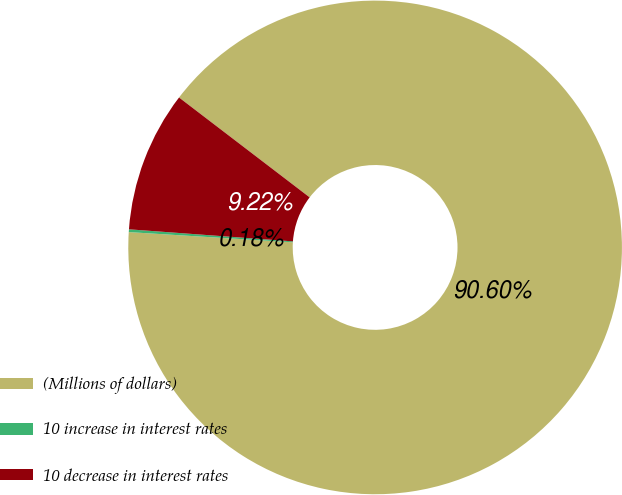Convert chart. <chart><loc_0><loc_0><loc_500><loc_500><pie_chart><fcel>(Millions of dollars)<fcel>10 increase in interest rates<fcel>10 decrease in interest rates<nl><fcel>90.6%<fcel>0.18%<fcel>9.22%<nl></chart> 